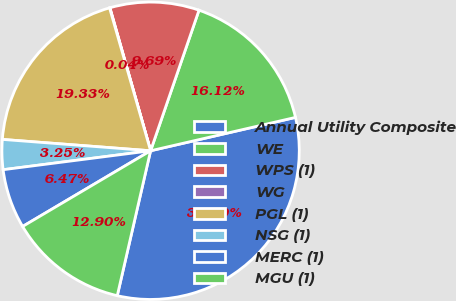Convert chart to OTSL. <chart><loc_0><loc_0><loc_500><loc_500><pie_chart><fcel>Annual Utility Composite<fcel>WE<fcel>WPS (1)<fcel>WG<fcel>PGL (1)<fcel>NSG (1)<fcel>MERC (1)<fcel>MGU (1)<nl><fcel>32.2%<fcel>16.12%<fcel>9.69%<fcel>0.04%<fcel>19.33%<fcel>3.25%<fcel>6.47%<fcel>12.9%<nl></chart> 